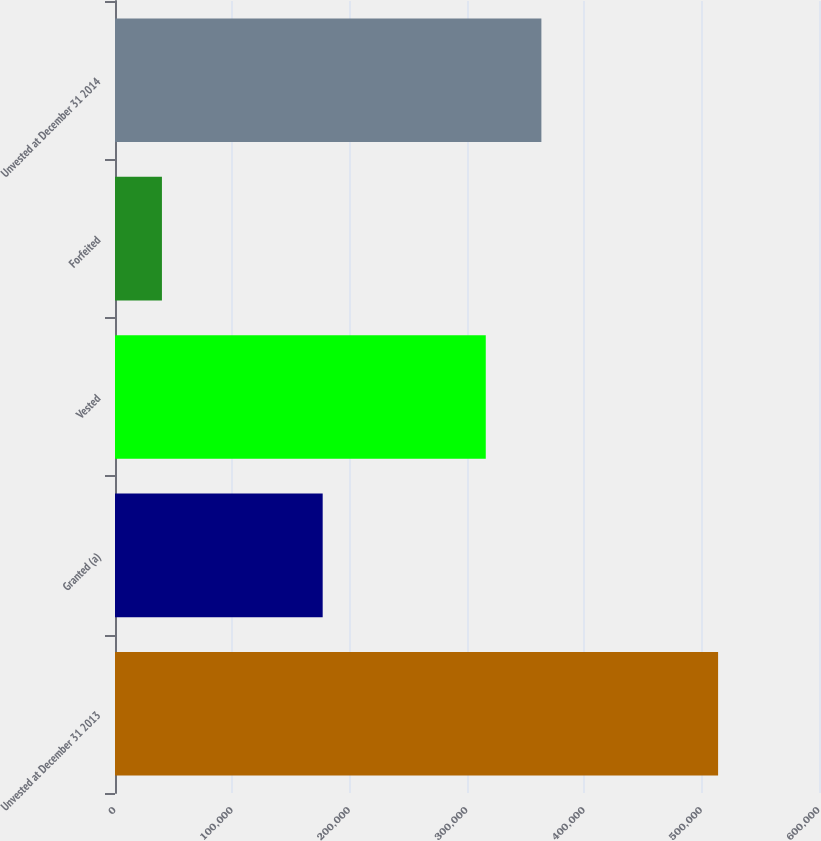Convert chart. <chart><loc_0><loc_0><loc_500><loc_500><bar_chart><fcel>Unvested at December 31 2013<fcel>Granted (a)<fcel>Vested<fcel>Forfeited<fcel>Unvested at December 31 2014<nl><fcel>514000<fcel>177000<fcel>316000<fcel>40000<fcel>363400<nl></chart> 